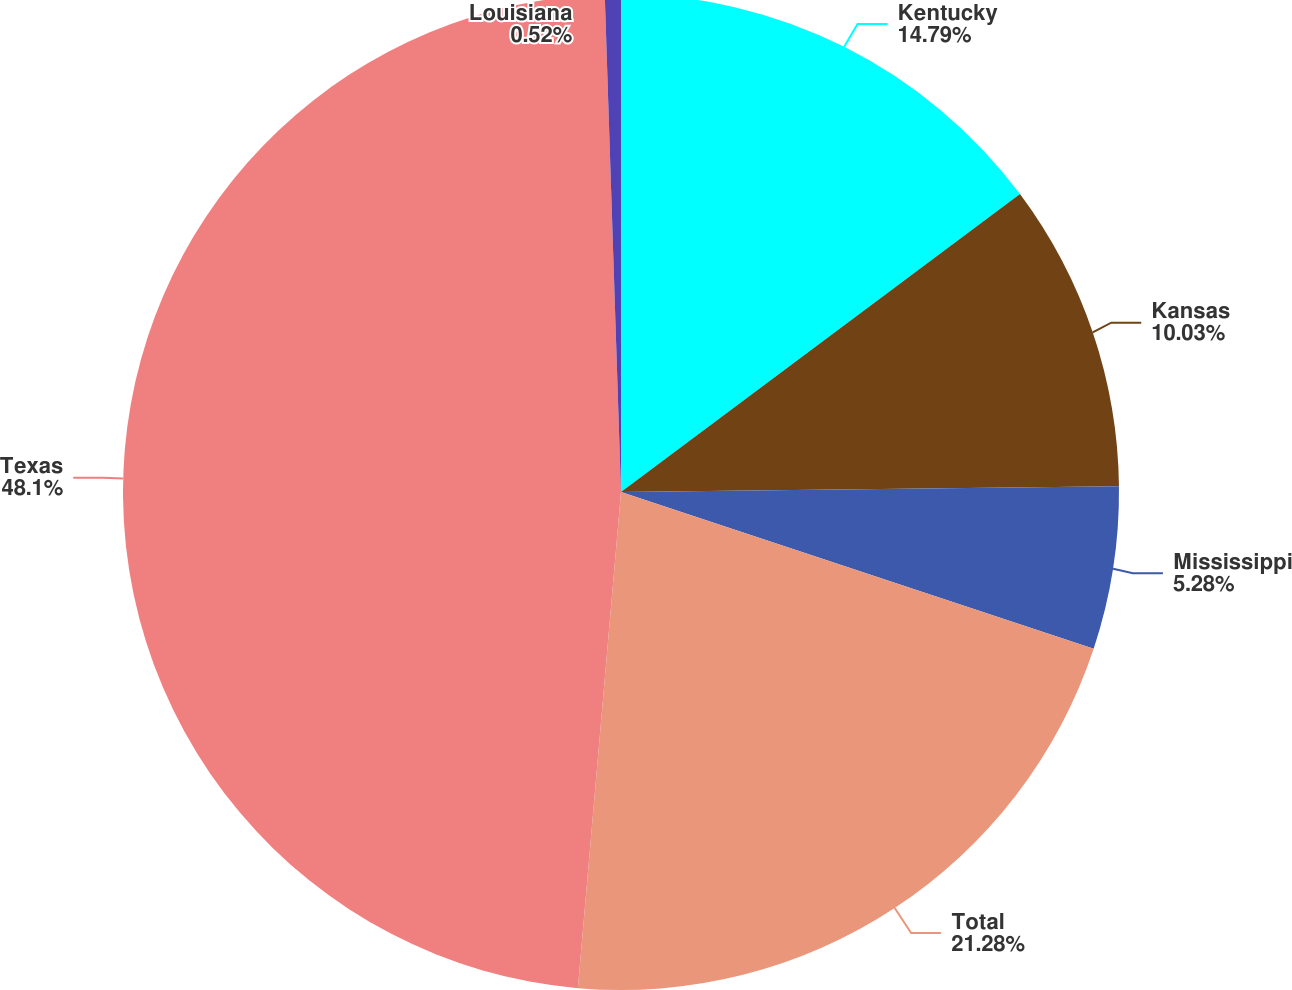<chart> <loc_0><loc_0><loc_500><loc_500><pie_chart><fcel>Kentucky<fcel>Kansas<fcel>Mississippi<fcel>Total<fcel>Texas<fcel>Louisiana<nl><fcel>14.79%<fcel>10.03%<fcel>5.28%<fcel>21.28%<fcel>48.1%<fcel>0.52%<nl></chart> 